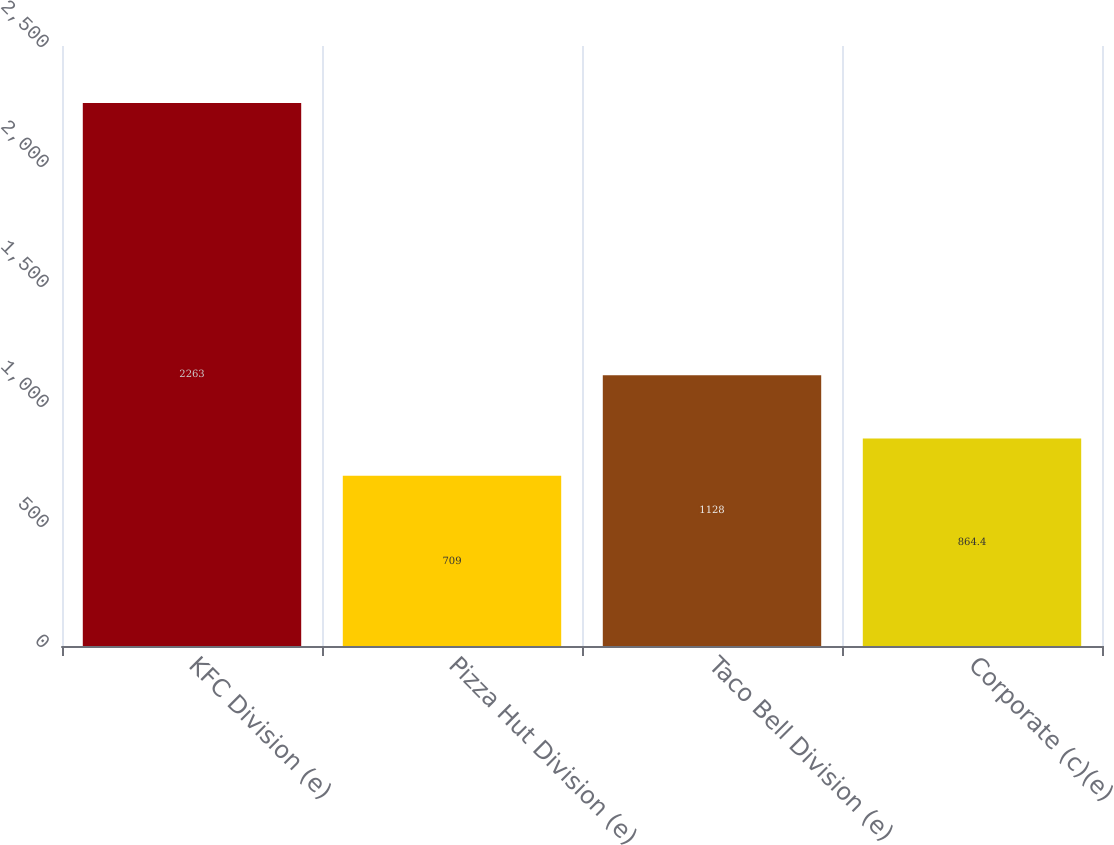<chart> <loc_0><loc_0><loc_500><loc_500><bar_chart><fcel>KFC Division (e)<fcel>Pizza Hut Division (e)<fcel>Taco Bell Division (e)<fcel>Corporate (c)(e)<nl><fcel>2263<fcel>709<fcel>1128<fcel>864.4<nl></chart> 